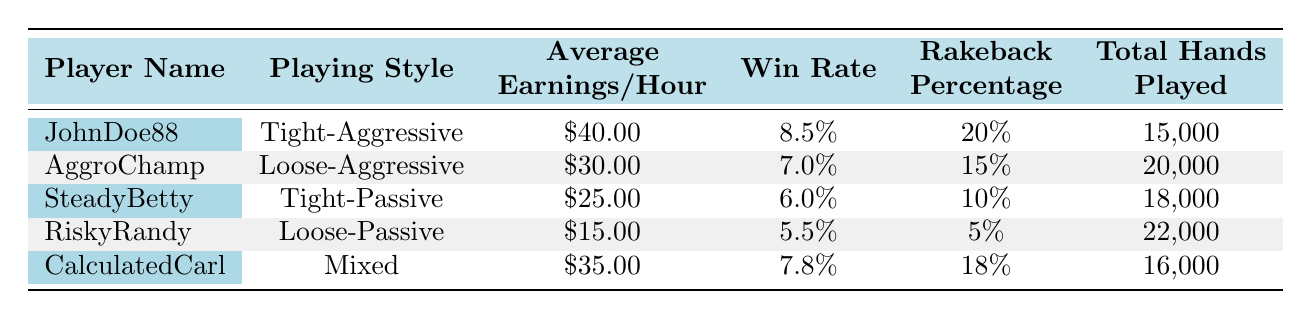What is the average earnings per hour for Tight-Aggressive players? In the table, under the "Average Earnings/Hour" column, the earnings for the Tight-Aggressive player "JohnDoe88" is given as 40.00. Since he is the only player in that style, his average is also the overall average for this group.
Answer: 40.00 What percentage of rakeback does RiskyRandy receive? Looking at the "Rakeback Percentage" column for RiskyRandy, it shows that he receives 5%.
Answer: 5% Which playing style has the highest win rate? By examining the "Win Rate" column for all players, JohnDoe88 has the highest win rate of 8.5%, which is greater than any other player's win rate in the table.
Answer: Tight-Aggressive What is the total number of hands played by players using Loose-Aggressive and Loose-Passive styles? From the "Total Hands Played" column, AggroChamp (Loose-Aggressive) has 20,000 hands, and RiskyRandy (Loose-Passive) has 22,000 hands. Adding these together gives 20,000 + 22,000 = 42,000.
Answer: 42,000 Is there a player with an average earnings per hour of more than 35.00? Checking the "Average Earnings/Hour" column, JohnDoe88 has 40.00, which is greater than 35.00. Thus, the statement is true.
Answer: Yes What is the difference in win rate between Tight-Aggressive and Tight-Passive players? JohnDoe88 (Tight-Aggressive) has a win rate of 8.5% and SteadyBetty (Tight-Passive) has a win rate of 6.0%. The difference is 8.5 - 6.0 = 2.5%.
Answer: 2.5% Who has the highest average earnings per hour among all players, and what is that amount? Reviewing the "Average Earnings/Hour" column, JohnDoe88 has the highest earnings at 40.00.
Answer: JohnDoe88, 40.00 What is the average rakeback percentage across all players? Adding all the rakeback percentages (20 + 15 + 10 + 5 + 18) gives 68. Dividing by the number of players (5) results in an average of 68/5 = 13.6.
Answer: 13.6 Which player has the lowest total hands played, and how many is it? In the "Total Hands Played" column, RiskyRandy has the lowest at 22,000. This is the highest among the players, not the lowest, which is actually JohnDoe88 at 15,000.
Answer: JohnDoe88, 15,000 